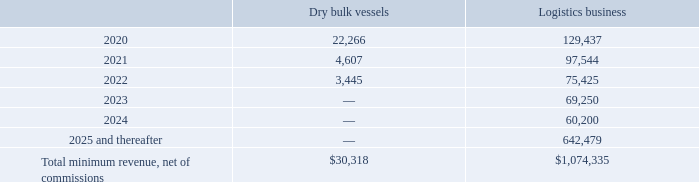NAVIOS MARITIME HOLDINGS INC. NOTES TO THE CONSOLIDATED FINANCIAL STATEMENTS (Expressed in thousands of U.S. dollars — except share data)
Chartered-out vessels, barges and pushboats:
The future minimum revenue, net of commissions, (i) for dry bulk vessels, expected to be earned on non-cancelable time charters; and (ii) for the Company’s logistics business, expected to be earned on non-cancelable time charters, COA’s with minimum guaranteed volumes and contracts with minimum guaranteed throughput in Navios Logistics’ ports expected to be earned on non-cancelable time charters, are as follows:
Revenues from time charters are not generally received when a vessel is off-hire, which includes time required for scheduled maintenance of the vessel.
What was the future minimum revenue for dry bulk vessels in 2020?
Answer scale should be: thousand. 22,266. What was the future minimum revenue for Logistics business in 2021?
Answer scale should be: thousand. 97,544. What was the Total minimum revenue, net of commissions for dry bulk vessels?
Answer scale should be: thousand. 30,318. What was the difference in the total minimum revenue between dry bulk vessels and logistics business?
Answer scale should be: thousand. 1,074,335-30,318
Answer: 1044017. What was the difference in the minimum revenue from dry bulk vessels between 2020 and 2021?
Answer scale should be: thousand. 22,266-4,607
Answer: 17659. What was the difference in the minimum revenue for logistics business between 2022 and 2023?
Answer scale should be: thousand. 75,425-69,250
Answer: 6175. 